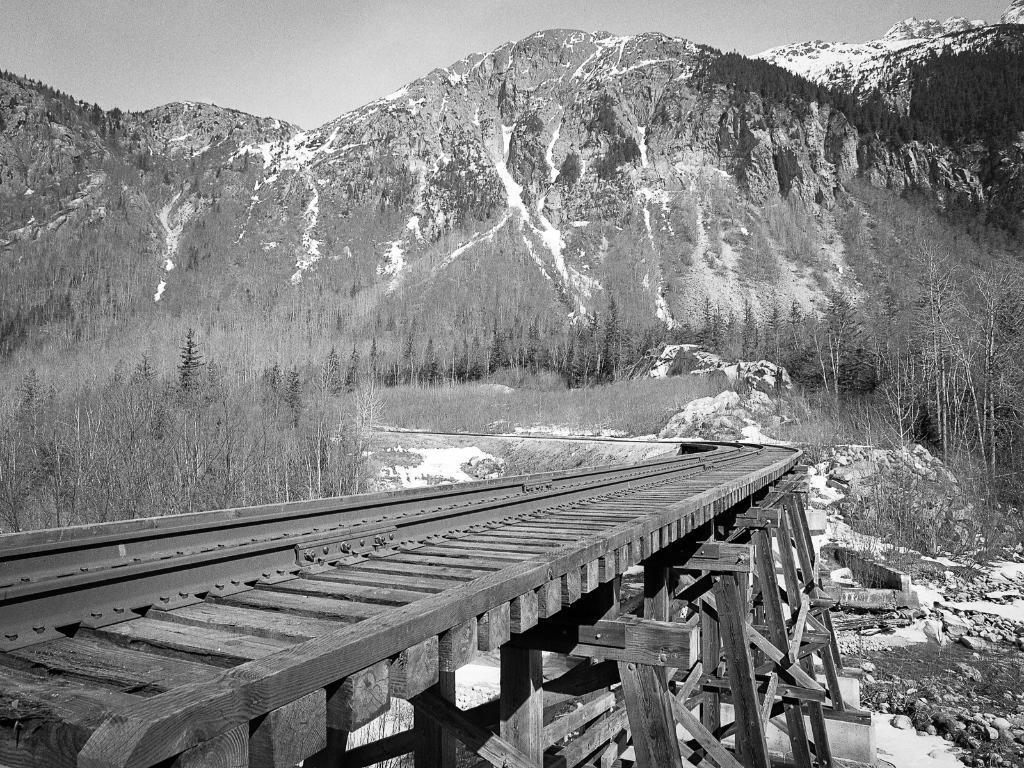What is located in the foreground of the image? There is a railway track and rocks in the foreground of the image. What can be seen in the middle of the image? There are trees in the middle of the image. What type of natural features are visible at the top of the image? There are hills visible at the top of the image. What is visible in the background of the image? The sky is visible at the top of the image. What type of hose is connected to the pump in the image? There is no hose or pump present in the image. What is your opinion on the scenery depicted in the image? As an AI, I do not have opinions, but the image features a railway track, rocks, trees, hills, and the sky, which together create a scenic view. 